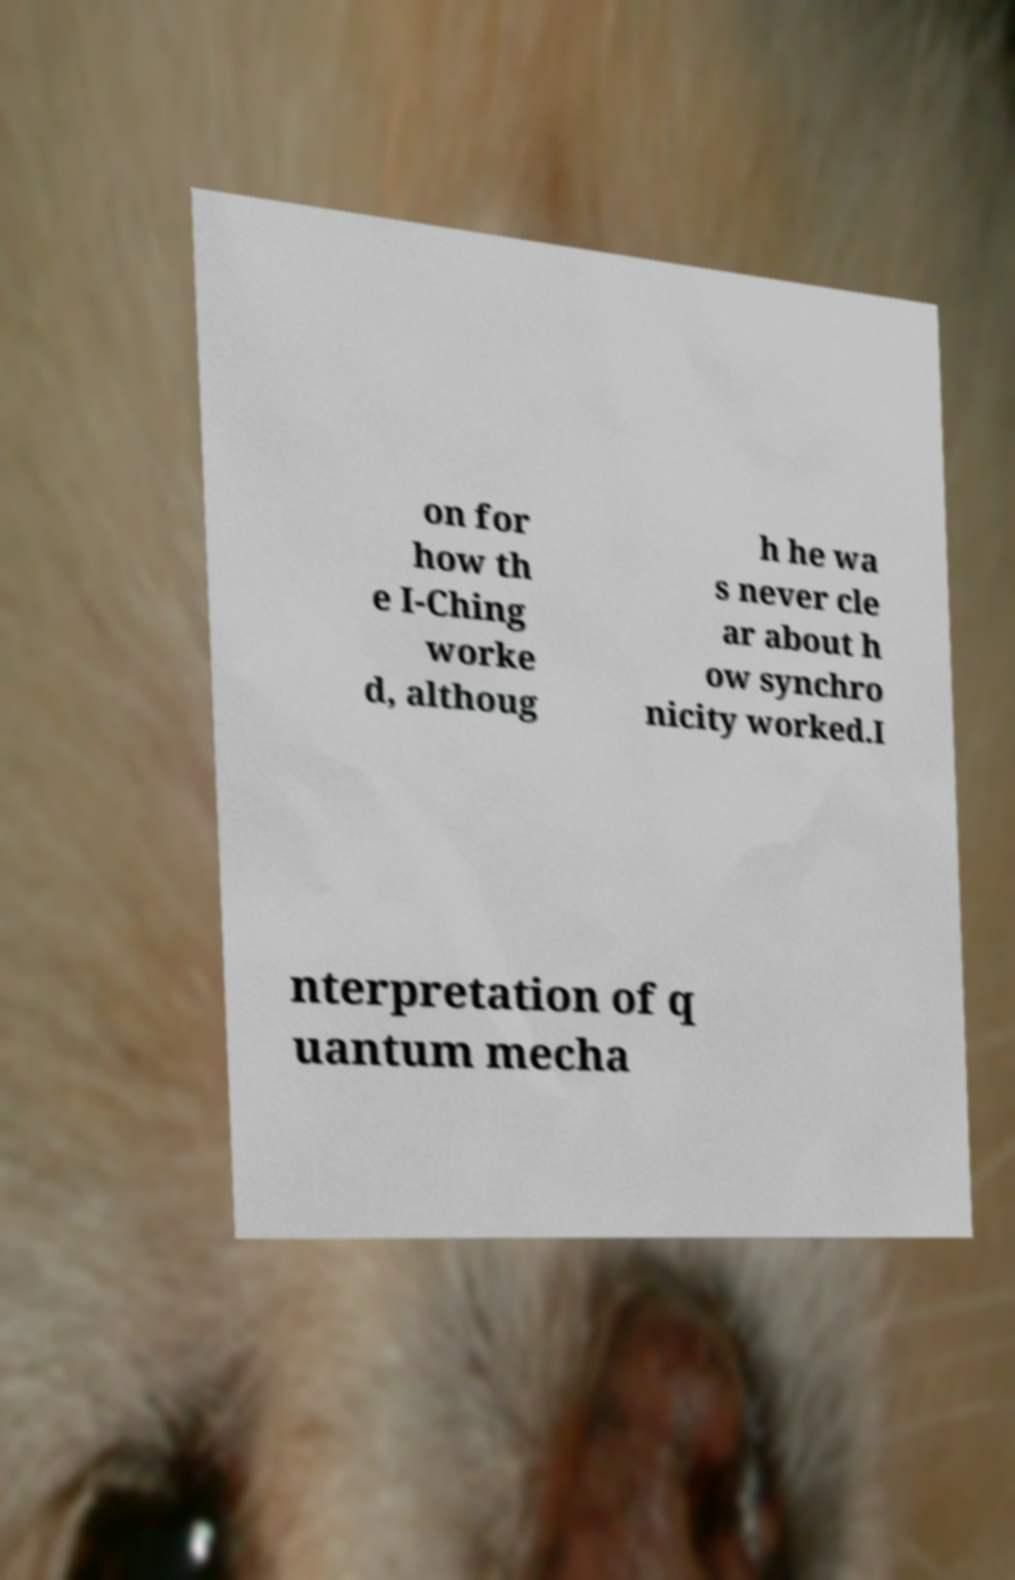Can you accurately transcribe the text from the provided image for me? on for how th e I-Ching worke d, althoug h he wa s never cle ar about h ow synchro nicity worked.I nterpretation of q uantum mecha 